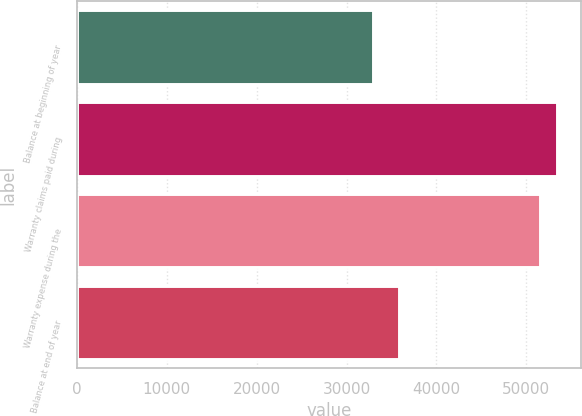Convert chart to OTSL. <chart><loc_0><loc_0><loc_500><loc_500><bar_chart><fcel>Balance at beginning of year<fcel>Warranty claims paid during<fcel>Warranty expense during the<fcel>Balance at end of year<nl><fcel>32930<fcel>53418.1<fcel>51510<fcel>35818<nl></chart> 